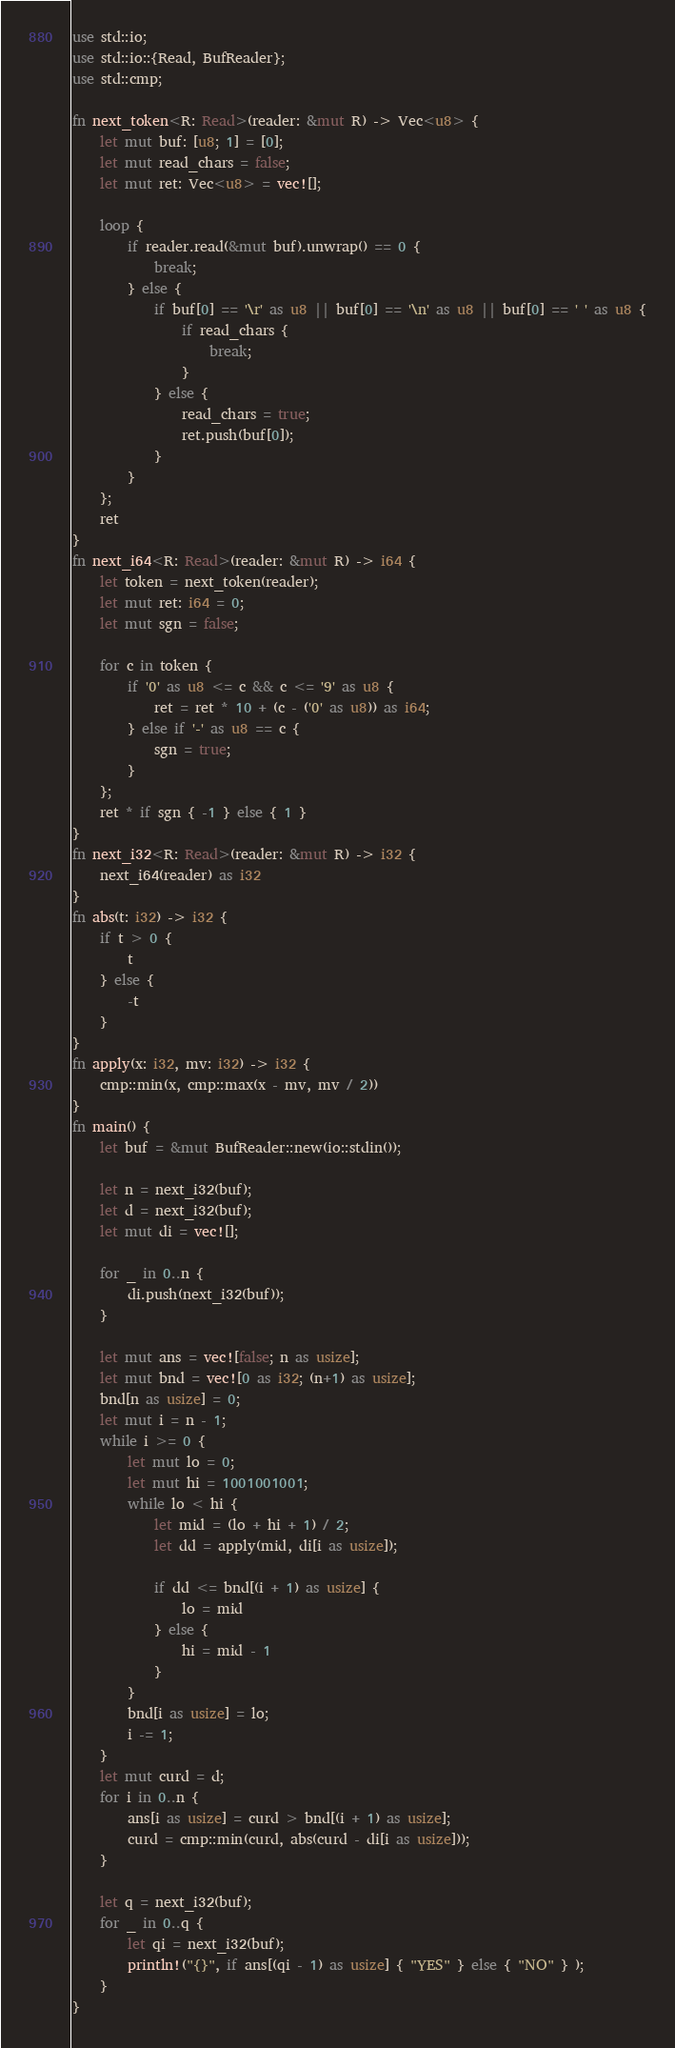<code> <loc_0><loc_0><loc_500><loc_500><_Rust_>use std::io;
use std::io::{Read, BufReader};
use std::cmp;

fn next_token<R: Read>(reader: &mut R) -> Vec<u8> {
    let mut buf: [u8; 1] = [0];
    let mut read_chars = false;
    let mut ret: Vec<u8> = vec![];

    loop {
        if reader.read(&mut buf).unwrap() == 0 {
            break;
        } else {
            if buf[0] == '\r' as u8 || buf[0] == '\n' as u8 || buf[0] == ' ' as u8 {
                if read_chars {
                    break;
                }
            } else {
                read_chars = true;
                ret.push(buf[0]);
            }
        }
    };
    ret
}
fn next_i64<R: Read>(reader: &mut R) -> i64 {
    let token = next_token(reader);
    let mut ret: i64 = 0;
    let mut sgn = false;

    for c in token {
        if '0' as u8 <= c && c <= '9' as u8 {
            ret = ret * 10 + (c - ('0' as u8)) as i64;
        } else if '-' as u8 == c {
            sgn = true;
        }
    };
    ret * if sgn { -1 } else { 1 }
}
fn next_i32<R: Read>(reader: &mut R) -> i32 {
    next_i64(reader) as i32
}
fn abs(t: i32) -> i32 {
    if t > 0 {
        t
    } else {
        -t
    }
}
fn apply(x: i32, mv: i32) -> i32 {
    cmp::min(x, cmp::max(x - mv, mv / 2))
}
fn main() {
    let buf = &mut BufReader::new(io::stdin());

    let n = next_i32(buf);
    let d = next_i32(buf);
    let mut di = vec![];

    for _ in 0..n {
        di.push(next_i32(buf));
    }

    let mut ans = vec![false; n as usize];
    let mut bnd = vec![0 as i32; (n+1) as usize];
    bnd[n as usize] = 0;
    let mut i = n - 1;
    while i >= 0 {
        let mut lo = 0;
        let mut hi = 1001001001;
        while lo < hi {
            let mid = (lo + hi + 1) / 2;
            let dd = apply(mid, di[i as usize]);

            if dd <= bnd[(i + 1) as usize] {
                lo = mid
            } else {
                hi = mid - 1
            }
        }
        bnd[i as usize] = lo;
        i -= 1;
    }
    let mut curd = d;
    for i in 0..n {
        ans[i as usize] = curd > bnd[(i + 1) as usize];
        curd = cmp::min(curd, abs(curd - di[i as usize]));
    }

    let q = next_i32(buf);
    for _ in 0..q {
        let qi = next_i32(buf);
        println!("{}", if ans[(qi - 1) as usize] { "YES" } else { "NO" } );
    }
}
</code> 